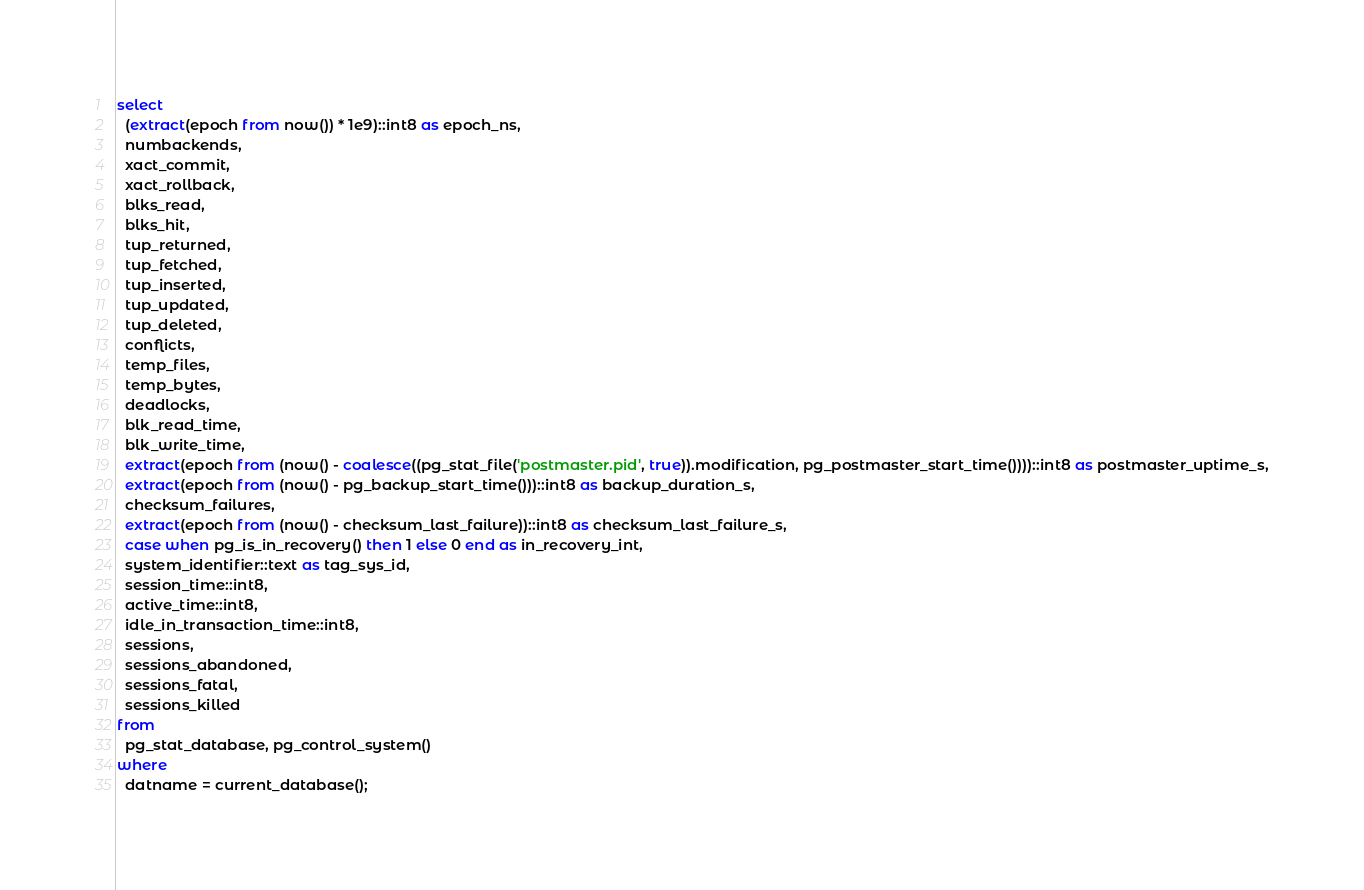<code> <loc_0><loc_0><loc_500><loc_500><_SQL_>select
  (extract(epoch from now()) * 1e9)::int8 as epoch_ns,
  numbackends,
  xact_commit,
  xact_rollback,
  blks_read,
  blks_hit,
  tup_returned,
  tup_fetched,
  tup_inserted,
  tup_updated,
  tup_deleted,
  conflicts,
  temp_files,
  temp_bytes,
  deadlocks,
  blk_read_time,
  blk_write_time,
  extract(epoch from (now() - coalesce((pg_stat_file('postmaster.pid', true)).modification, pg_postmaster_start_time())))::int8 as postmaster_uptime_s,
  extract(epoch from (now() - pg_backup_start_time()))::int8 as backup_duration_s,
  checksum_failures,
  extract(epoch from (now() - checksum_last_failure))::int8 as checksum_last_failure_s,
  case when pg_is_in_recovery() then 1 else 0 end as in_recovery_int,
  system_identifier::text as tag_sys_id,
  session_time::int8,
  active_time::int8,
  idle_in_transaction_time::int8,
  sessions,
  sessions_abandoned,
  sessions_fatal,
  sessions_killed
from
  pg_stat_database, pg_control_system()
where
  datname = current_database();
</code> 